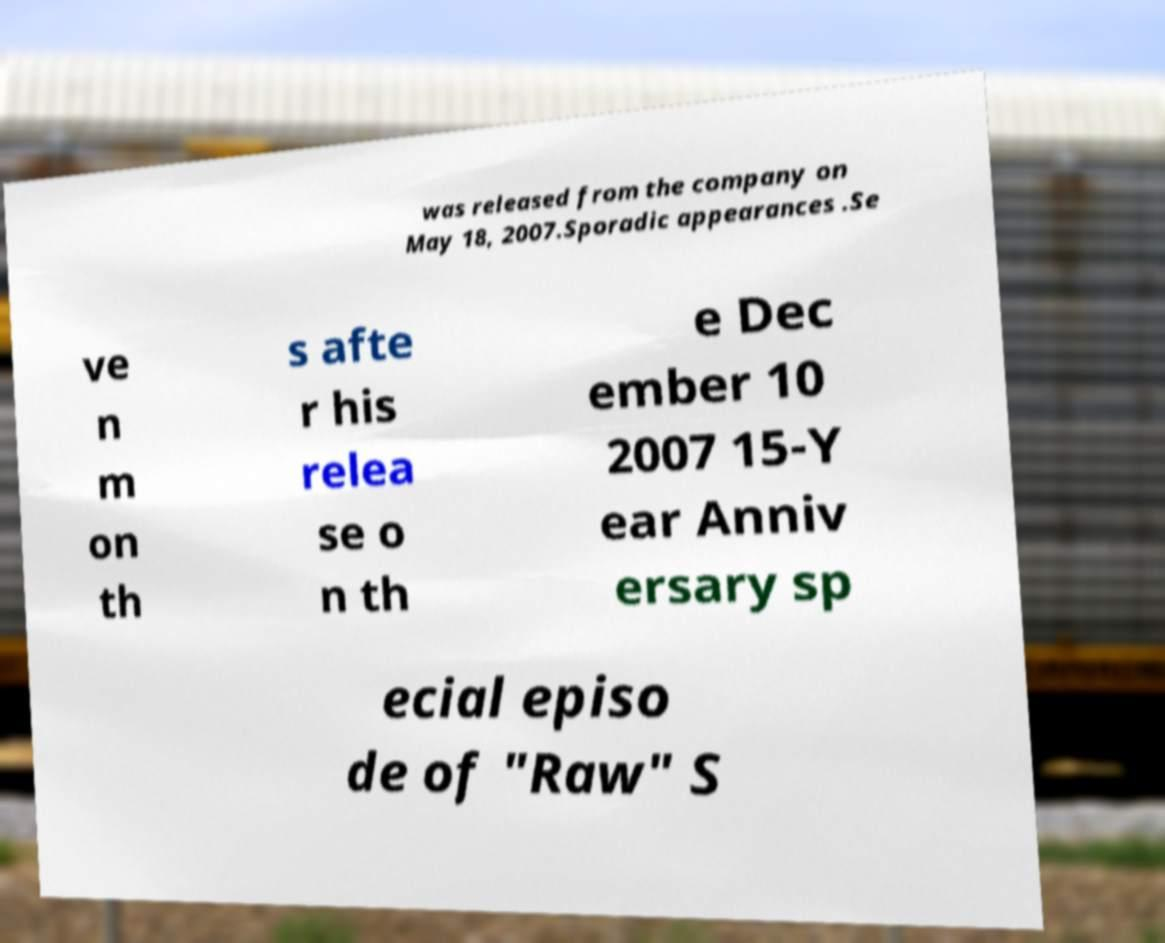What messages or text are displayed in this image? I need them in a readable, typed format. was released from the company on May 18, 2007.Sporadic appearances .Se ve n m on th s afte r his relea se o n th e Dec ember 10 2007 15-Y ear Anniv ersary sp ecial episo de of "Raw" S 